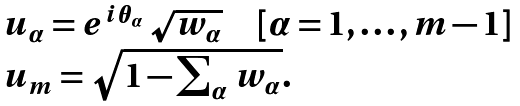<formula> <loc_0><loc_0><loc_500><loc_500>\begin{array} { l } u _ { \alpha } = e ^ { i \theta _ { \alpha } } \, \sqrt { w _ { \alpha } } \quad [ \alpha = 1 , \dots , m - 1 ] \\ u _ { m } = \sqrt { 1 - \sum _ { \alpha } \, w _ { \alpha } } . \end{array}</formula> 